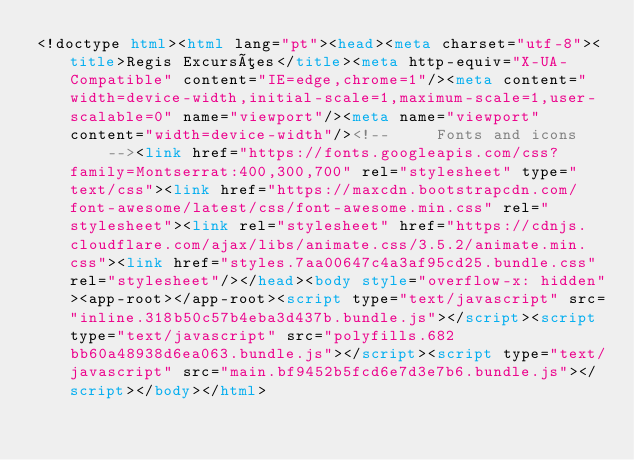Convert code to text. <code><loc_0><loc_0><loc_500><loc_500><_HTML_><!doctype html><html lang="pt"><head><meta charset="utf-8"><title>Regis Excursões</title><meta http-equiv="X-UA-Compatible" content="IE=edge,chrome=1"/><meta content="width=device-width,initial-scale=1,maximum-scale=1,user-scalable=0" name="viewport"/><meta name="viewport" content="width=device-width"/><!--     Fonts and icons     --><link href="https://fonts.googleapis.com/css?family=Montserrat:400,300,700" rel="stylesheet" type="text/css"><link href="https://maxcdn.bootstrapcdn.com/font-awesome/latest/css/font-awesome.min.css" rel="stylesheet"><link rel="stylesheet" href="https://cdnjs.cloudflare.com/ajax/libs/animate.css/3.5.2/animate.min.css"><link href="styles.7aa00647c4a3af95cd25.bundle.css" rel="stylesheet"/></head><body style="overflow-x: hidden"><app-root></app-root><script type="text/javascript" src="inline.318b50c57b4eba3d437b.bundle.js"></script><script type="text/javascript" src="polyfills.682bb60a48938d6ea063.bundle.js"></script><script type="text/javascript" src="main.bf9452b5fcd6e7d3e7b6.bundle.js"></script></body></html></code> 